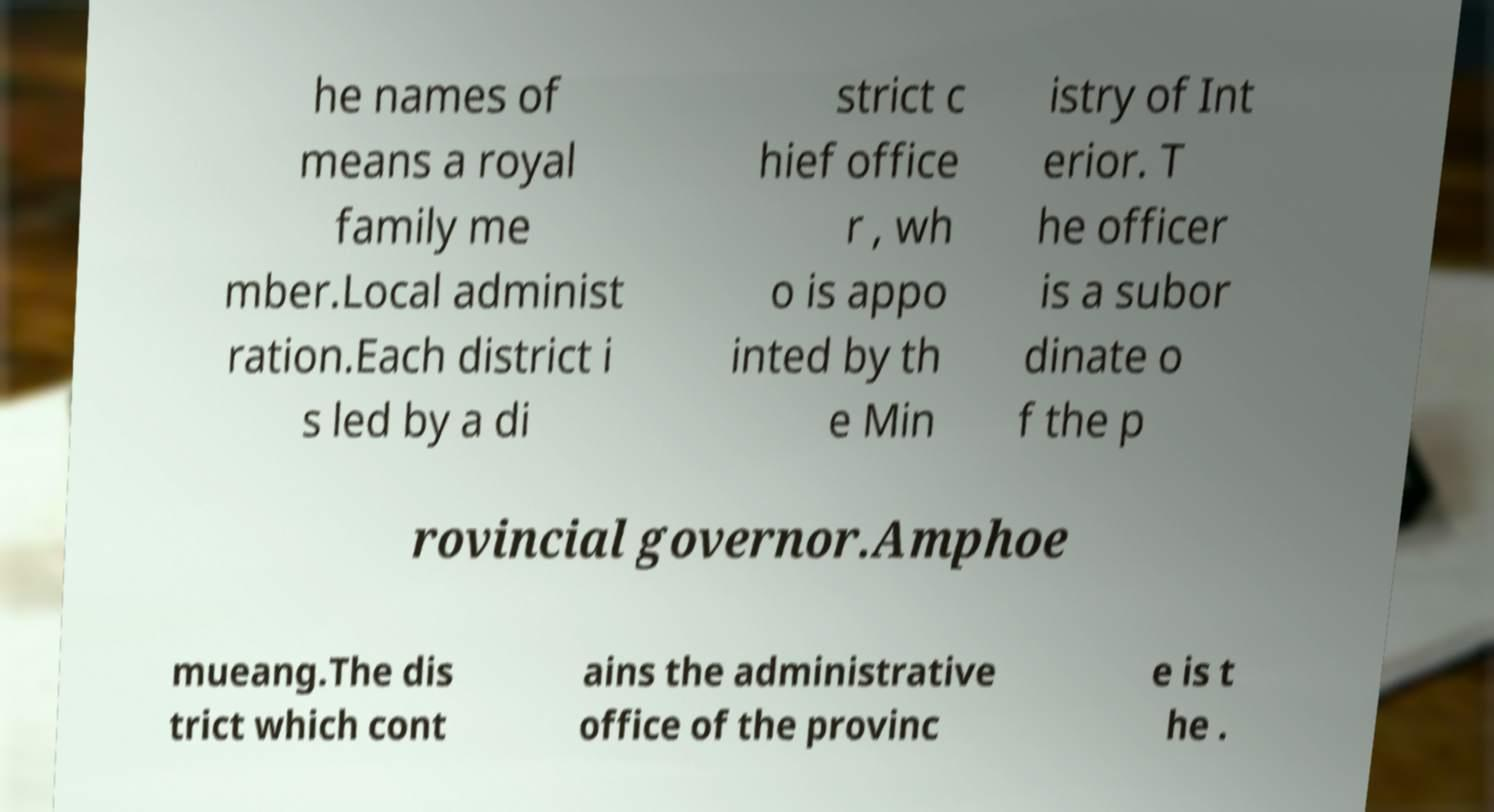Please identify and transcribe the text found in this image. he names of means a royal family me mber.Local administ ration.Each district i s led by a di strict c hief office r , wh o is appo inted by th e Min istry of Int erior. T he officer is a subor dinate o f the p rovincial governor.Amphoe mueang.The dis trict which cont ains the administrative office of the provinc e is t he . 